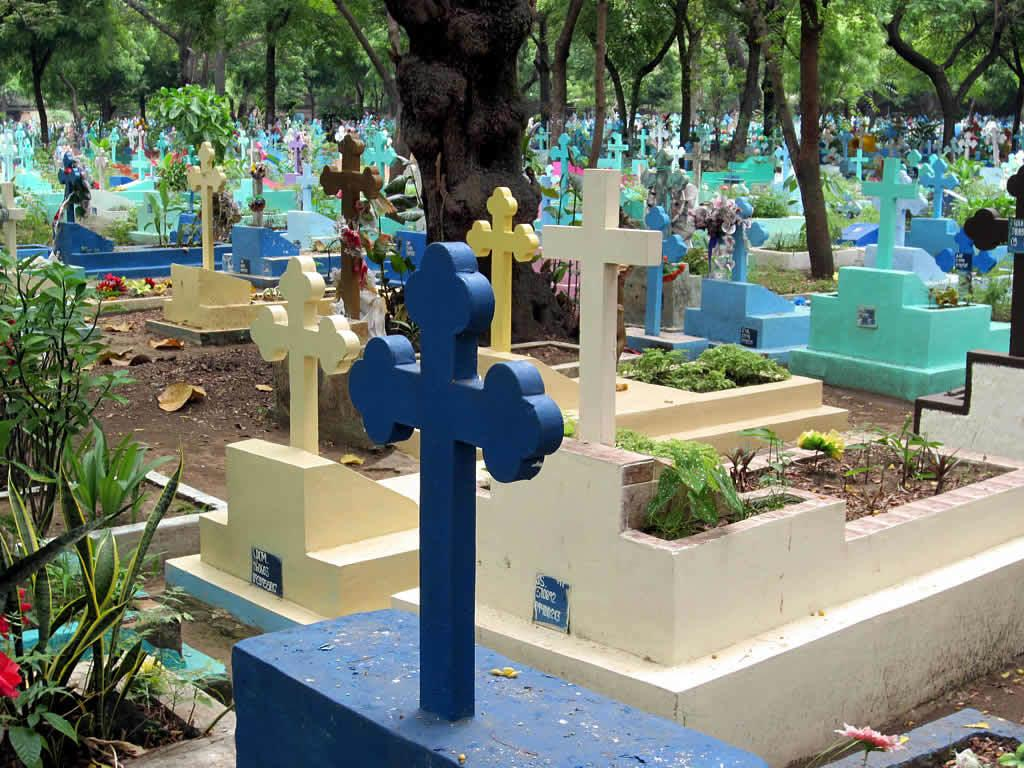What type of location is depicted in the image? The image contains cemeteries. What natural elements can be seen in the image? There are trees in the image. What is visible at the bottom of the image? The ground is visible at the bottom of the image. What is present on the ground in the image? Dried leaves are present on the ground. What type of ocean can be seen in the image? There is no ocean present in the image; it contains cemeteries and trees. What song is being sung by the trees in the image? Trees do not sing songs, so there is no song being sung in the image. 